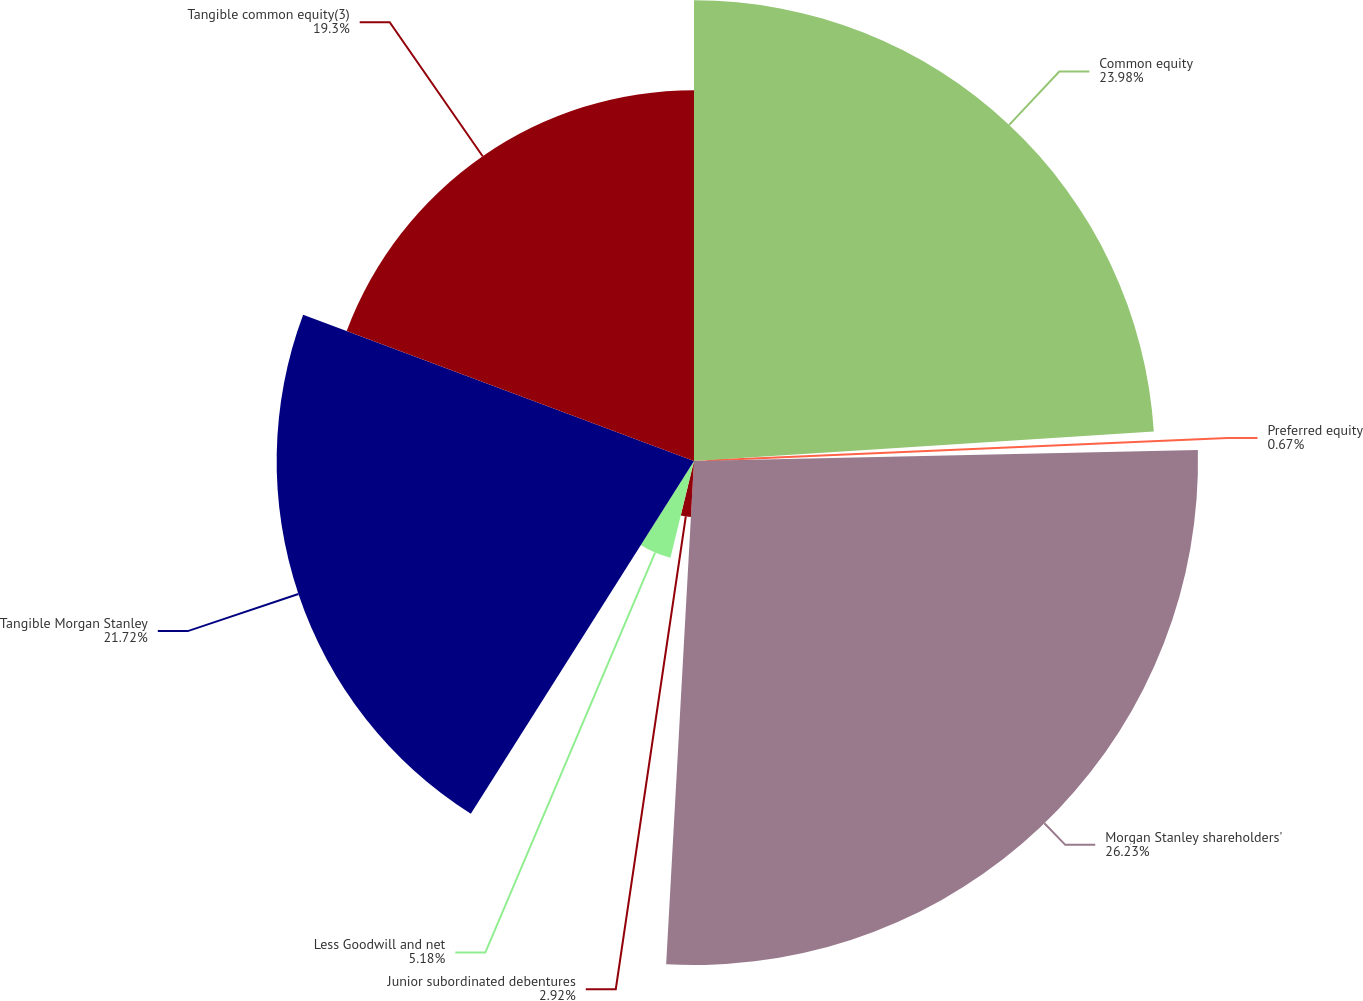<chart> <loc_0><loc_0><loc_500><loc_500><pie_chart><fcel>Common equity<fcel>Preferred equity<fcel>Morgan Stanley shareholders'<fcel>Junior subordinated debentures<fcel>Less Goodwill and net<fcel>Tangible Morgan Stanley<fcel>Tangible common equity(3)<nl><fcel>23.98%<fcel>0.67%<fcel>26.23%<fcel>2.92%<fcel>5.18%<fcel>21.72%<fcel>19.3%<nl></chart> 